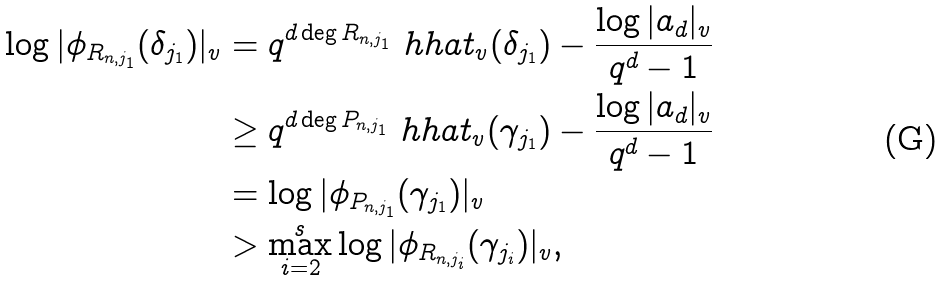Convert formula to latex. <formula><loc_0><loc_0><loc_500><loc_500>\log | \phi _ { R _ { n , j _ { 1 } } } ( \delta _ { j _ { 1 } } ) | _ { v } & = q ^ { d \deg R _ { n , j _ { 1 } } } \ h h a t _ { v } ( \delta _ { j _ { 1 } } ) - \frac { \log | a _ { d } | _ { v } } { q ^ { d } - 1 } \\ & \geq q ^ { d \deg P _ { n , j _ { 1 } } } \ h h a t _ { v } ( \gamma _ { j _ { 1 } } ) - \frac { \log | a _ { d } | _ { v } } { q ^ { d } - 1 } \\ & = \log | \phi _ { P _ { n , j _ { 1 } } } ( \gamma _ { j _ { 1 } } ) | _ { v } \\ & > \max _ { i = 2 } ^ { s } \log | \phi _ { R _ { n , j _ { i } } } ( \gamma _ { j _ { i } } ) | _ { v } ,</formula> 